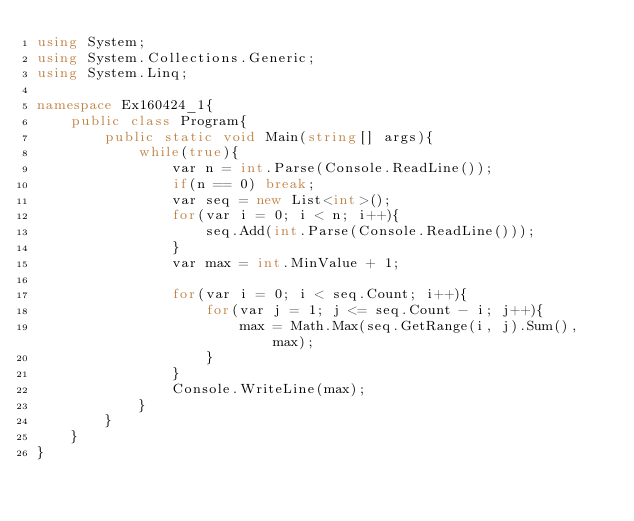<code> <loc_0><loc_0><loc_500><loc_500><_C#_>using System;
using System.Collections.Generic;
using System.Linq;

namespace Ex160424_1{
    public class Program{
        public static void Main(string[] args){
            while(true){
                var n = int.Parse(Console.ReadLine());
                if(n == 0) break;
                var seq = new List<int>();
                for(var i = 0; i < n; i++){
                    seq.Add(int.Parse(Console.ReadLine()));
                }
                var max = int.MinValue + 1;

                for(var i = 0; i < seq.Count; i++){
                    for(var j = 1; j <= seq.Count - i; j++){
                        max = Math.Max(seq.GetRange(i, j).Sum(), max);
                    }
                }
                Console.WriteLine(max);
            }
        }
    }
}</code> 